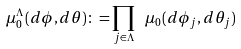<formula> <loc_0><loc_0><loc_500><loc_500>\mu _ { 0 } ^ { \Lambda } ( d \phi , d \theta ) \colon = \prod _ { j \in \Lambda } \ \mu _ { 0 } ( d \phi _ { j } , d \theta _ { j } )</formula> 